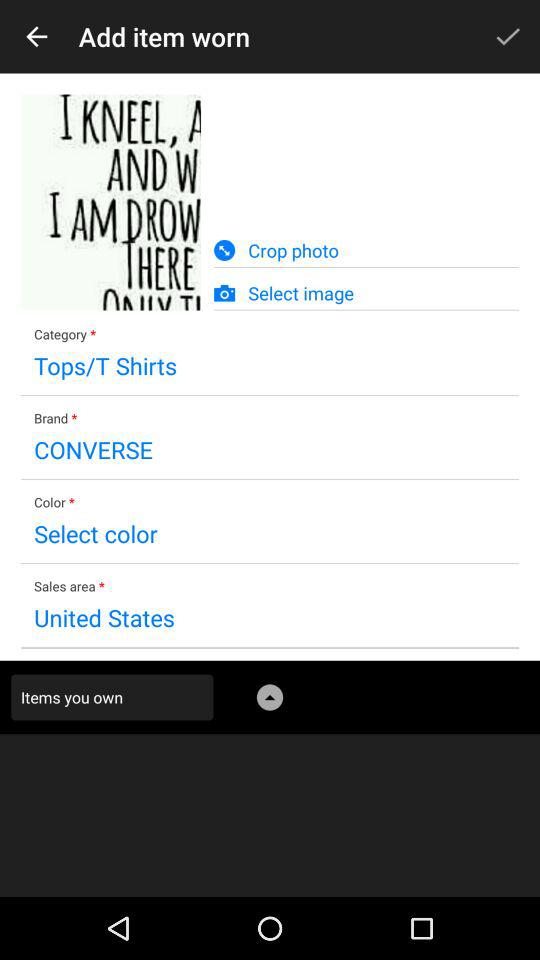How many text inputs are required to add an item worn?
Answer the question using a single word or phrase. 4 